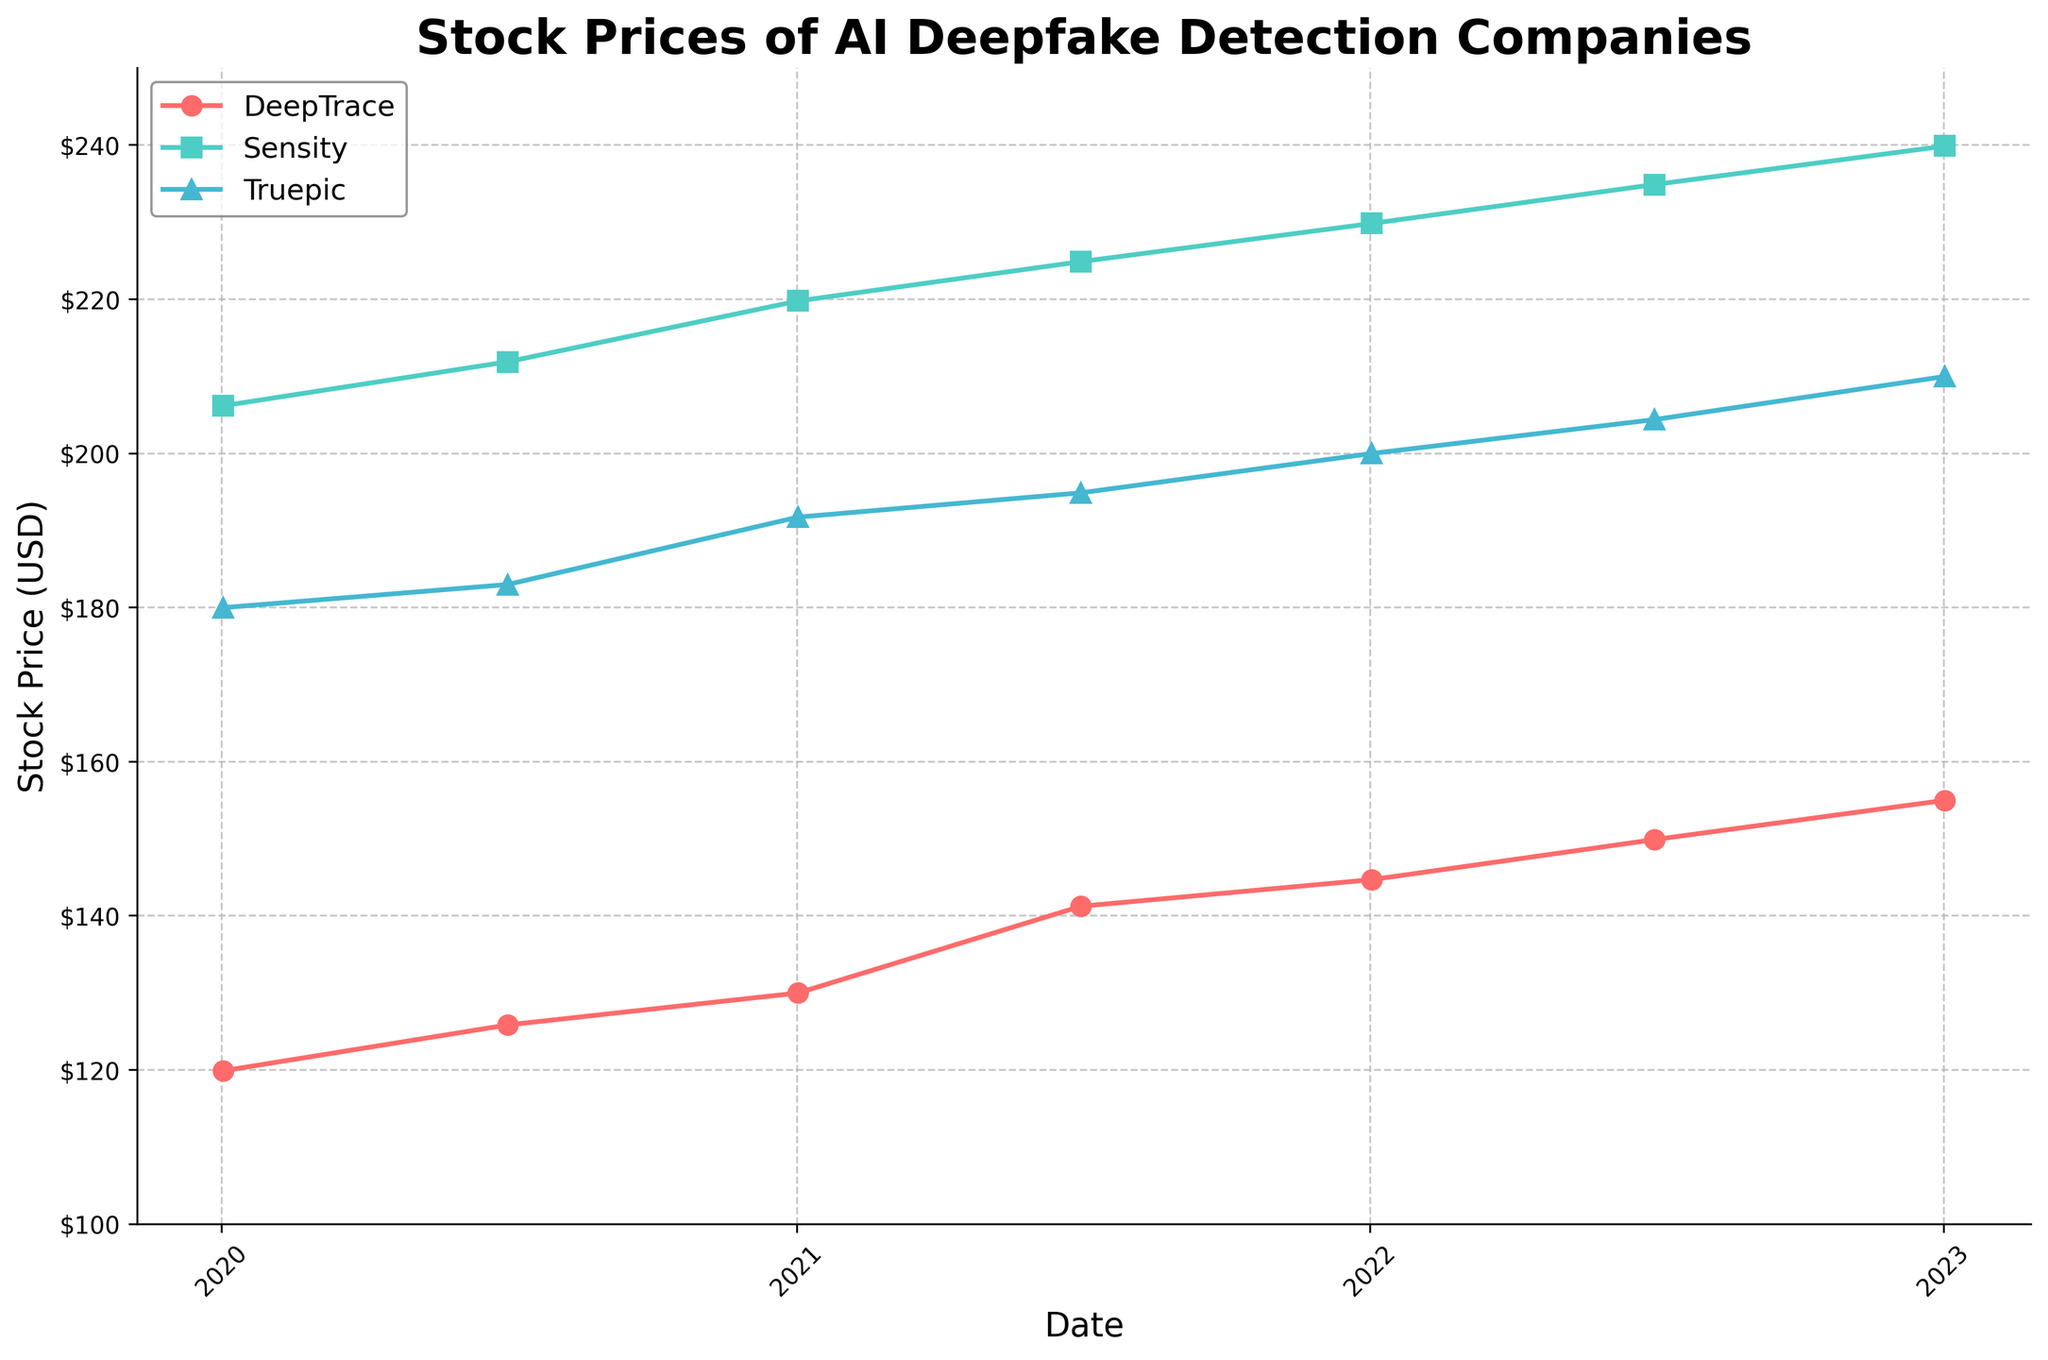what is the title of this figure? The title of the figure is typically located at the top and is written in larger, bold text. From the given code, the title is "Stock Prices of AI Deepfake Detection Companies".
Answer: Stock Prices of AI Deepfake Detection Companies Which company had the highest stock price at the beginning of 2023? By looking at the last data point for the start of 2023 (January 2, 2023), compare the "Close" stock prices of all companies listed for that date. Sensity had the highest closing stock price of $239.85.
Answer: Sensity What was the closing stock price for DeepTrace on January 2, 2021? Find the date January 2, 2021, and locate the closing stock price for DeepTrace, which is $129.95.
Answer: $129.95 How did the stock price of Truepic change from July 1, 2022 to January 2, 2023? Compare the "Close" prices for Truepic on July 1, 2022 ($204.35) and January 2, 2023 ($209.95). The stock price increased by just subtracting the earlier price from the later price: 209.95 - 204.35 = 5.60.
Answer: Increased by $5.60 Between which two dates did the stock price of DeepTrace show the greatest increase? Evaluate the closing prices on each date for DeepTrace: [119.85, 125.80, 129.95, 141.20, 144.65, 149.85, 154.95]. The greatest increase is between July 1, 2021, and January 2, 2022, where the price increased from $141.20 to $144.65.
Answer: July 1, 2021, and January 2, 2022 How many companies are compared in this plot? Look at the legend or the unique markers/colors used in the line plot, which correspond to different companies. The three companies presented are DeepTrace, Sensity, and Truepic.
Answer: 3 Which company displayed the most consistent increasing trend from 2020 to 2023? By observing the trajectories of the lines for each company, DeepTrace shows a consistent and steady increase in its closing prices from 2020 to 2023 without any significant drops.
Answer: DeepTrace What is the relative difference in closing stock prices between Sensity and Truepic on January 2, 2022? Compare the "Close" stock prices for Sensity ($229.80) and Truepic ($199.95) on January 2, 2022. Calculate the difference using the formula: Sensity - Truepic = 229.80 - 199.95 = 29.85.
Answer: $29.85 What's the average closing stock price for Truepic in the available data? Sum the "Close" prices for Truepic: (179.95 + 182.95 + 191.70 + 194.85 + 199.95 + 204.35 + 209.95 = 1364.7) and divide by the number of data points (7). 1364.7 / 7 = 195.24.
Answer: $195.24 